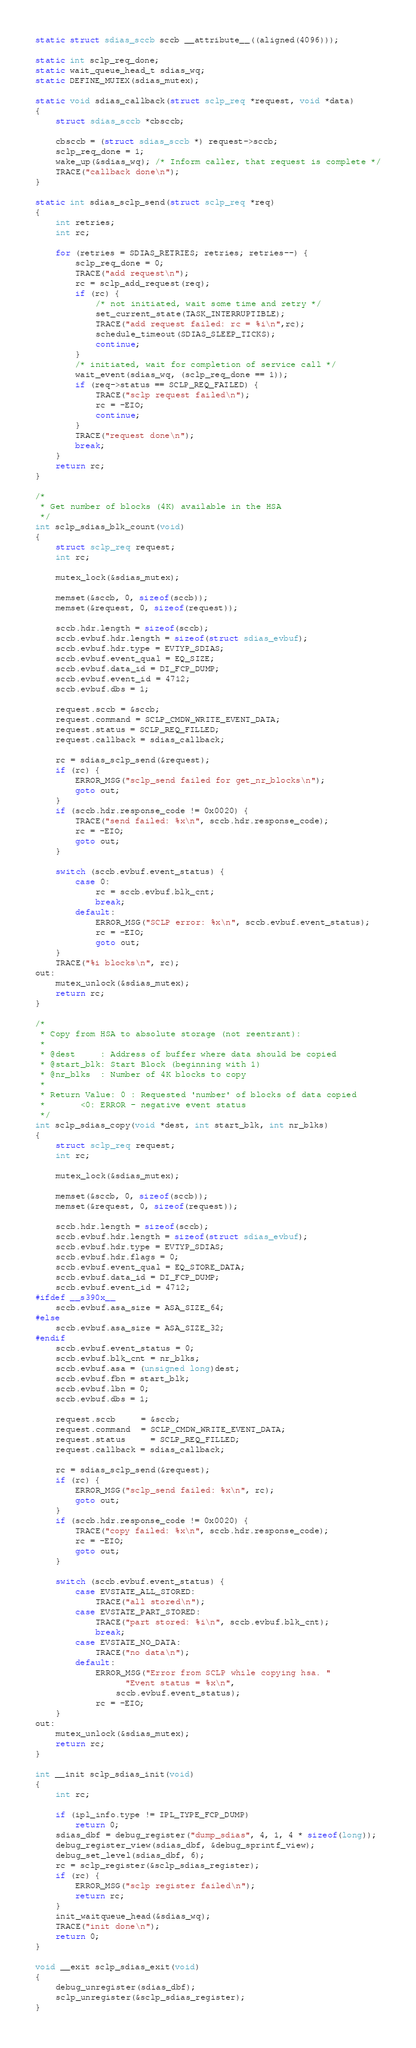<code> <loc_0><loc_0><loc_500><loc_500><_C_>static struct sdias_sccb sccb __attribute__((aligned(4096)));

static int sclp_req_done;
static wait_queue_head_t sdias_wq;
static DEFINE_MUTEX(sdias_mutex);

static void sdias_callback(struct sclp_req *request, void *data)
{
	struct sdias_sccb *cbsccb;

	cbsccb = (struct sdias_sccb *) request->sccb;
	sclp_req_done = 1;
	wake_up(&sdias_wq); /* Inform caller, that request is complete */
	TRACE("callback done\n");
}

static int sdias_sclp_send(struct sclp_req *req)
{
	int retries;
	int rc;

	for (retries = SDIAS_RETRIES; retries; retries--) {
		sclp_req_done = 0;
		TRACE("add request\n");
		rc = sclp_add_request(req);
		if (rc) {
			/* not initiated, wait some time and retry */
			set_current_state(TASK_INTERRUPTIBLE);
			TRACE("add request failed: rc = %i\n",rc);
			schedule_timeout(SDIAS_SLEEP_TICKS);
			continue;
		}
		/* initiated, wait for completion of service call */
		wait_event(sdias_wq, (sclp_req_done == 1));
		if (req->status == SCLP_REQ_FAILED) {
			TRACE("sclp request failed\n");
			rc = -EIO;
			continue;
		}
		TRACE("request done\n");
		break;
	}
	return rc;
}

/*
 * Get number of blocks (4K) available in the HSA
 */
int sclp_sdias_blk_count(void)
{
	struct sclp_req request;
	int rc;

	mutex_lock(&sdias_mutex);

	memset(&sccb, 0, sizeof(sccb));
	memset(&request, 0, sizeof(request));

	sccb.hdr.length = sizeof(sccb);
	sccb.evbuf.hdr.length = sizeof(struct sdias_evbuf);
	sccb.evbuf.hdr.type = EVTYP_SDIAS;
	sccb.evbuf.event_qual = EQ_SIZE;
	sccb.evbuf.data_id = DI_FCP_DUMP;
	sccb.evbuf.event_id = 4712;
	sccb.evbuf.dbs = 1;

	request.sccb = &sccb;
	request.command = SCLP_CMDW_WRITE_EVENT_DATA;
	request.status = SCLP_REQ_FILLED;
	request.callback = sdias_callback;

	rc = sdias_sclp_send(&request);
	if (rc) {
		ERROR_MSG("sclp_send failed for get_nr_blocks\n");
		goto out;
	}
	if (sccb.hdr.response_code != 0x0020) {
		TRACE("send failed: %x\n", sccb.hdr.response_code);
		rc = -EIO;
		goto out;
	}

	switch (sccb.evbuf.event_status) {
		case 0:
			rc = sccb.evbuf.blk_cnt;
			break;
		default:
			ERROR_MSG("SCLP error: %x\n", sccb.evbuf.event_status);
			rc = -EIO;
			goto out;
	}
	TRACE("%i blocks\n", rc);
out:
	mutex_unlock(&sdias_mutex);
	return rc;
}

/*
 * Copy from HSA to absolute storage (not reentrant):
 *
 * @dest     : Address of buffer where data should be copied
 * @start_blk: Start Block (beginning with 1)
 * @nr_blks  : Number of 4K blocks to copy
 *
 * Return Value: 0 : Requested 'number' of blocks of data copied
 *		 <0: ERROR - negative event status
 */
int sclp_sdias_copy(void *dest, int start_blk, int nr_blks)
{
	struct sclp_req request;
	int rc;

	mutex_lock(&sdias_mutex);

	memset(&sccb, 0, sizeof(sccb));
	memset(&request, 0, sizeof(request));

	sccb.hdr.length = sizeof(sccb);
	sccb.evbuf.hdr.length = sizeof(struct sdias_evbuf);
	sccb.evbuf.hdr.type = EVTYP_SDIAS;
	sccb.evbuf.hdr.flags = 0;
	sccb.evbuf.event_qual = EQ_STORE_DATA;
	sccb.evbuf.data_id = DI_FCP_DUMP;
	sccb.evbuf.event_id = 4712;
#ifdef __s390x__
	sccb.evbuf.asa_size = ASA_SIZE_64;
#else
	sccb.evbuf.asa_size = ASA_SIZE_32;
#endif
	sccb.evbuf.event_status = 0;
	sccb.evbuf.blk_cnt = nr_blks;
	sccb.evbuf.asa = (unsigned long)dest;
	sccb.evbuf.fbn = start_blk;
	sccb.evbuf.lbn = 0;
	sccb.evbuf.dbs = 1;

	request.sccb	 = &sccb;
	request.command  = SCLP_CMDW_WRITE_EVENT_DATA;
	request.status	 = SCLP_REQ_FILLED;
	request.callback = sdias_callback;

	rc = sdias_sclp_send(&request);
	if (rc) {
		ERROR_MSG("sclp_send failed: %x\n", rc);
		goto out;
	}
	if (sccb.hdr.response_code != 0x0020) {
		TRACE("copy failed: %x\n", sccb.hdr.response_code);
		rc = -EIO;
		goto out;
	}

	switch (sccb.evbuf.event_status) {
		case EVSTATE_ALL_STORED:
			TRACE("all stored\n");
		case EVSTATE_PART_STORED:
			TRACE("part stored: %i\n", sccb.evbuf.blk_cnt);
			break;
		case EVSTATE_NO_DATA:
			TRACE("no data\n");
		default:
			ERROR_MSG("Error from SCLP while copying hsa. "
				  "Event status = %x\n",
				sccb.evbuf.event_status);
			rc = -EIO;
	}
out:
	mutex_unlock(&sdias_mutex);
	return rc;
}

int __init sclp_sdias_init(void)
{
	int rc;

	if (ipl_info.type != IPL_TYPE_FCP_DUMP)
		return 0;
	sdias_dbf = debug_register("dump_sdias", 4, 1, 4 * sizeof(long));
	debug_register_view(sdias_dbf, &debug_sprintf_view);
	debug_set_level(sdias_dbf, 6);
	rc = sclp_register(&sclp_sdias_register);
	if (rc) {
		ERROR_MSG("sclp register failed\n");
		return rc;
	}
	init_waitqueue_head(&sdias_wq);
	TRACE("init done\n");
	return 0;
}

void __exit sclp_sdias_exit(void)
{
	debug_unregister(sdias_dbf);
	sclp_unregister(&sclp_sdias_register);
}
</code> 